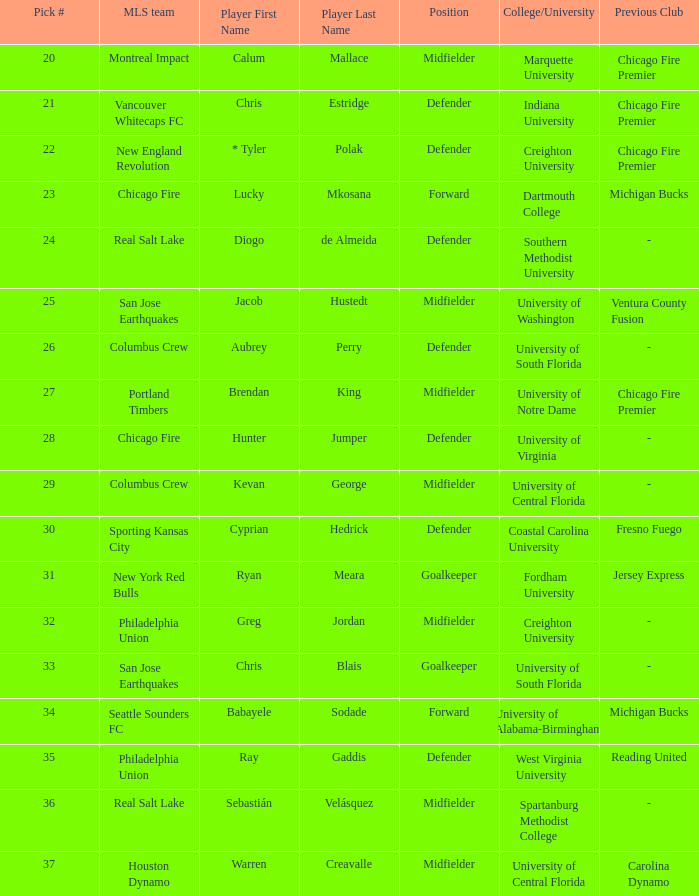I'm looking to parse the entire table for insights. Could you assist me with that? {'header': ['Pick #', 'MLS team', 'Player First Name', 'Player Last Name', 'Position', 'College/University', 'Previous Club'], 'rows': [['20', 'Montreal Impact', 'Calum', 'Mallace', 'Midfielder', 'Marquette University', 'Chicago Fire Premier'], ['21', 'Vancouver Whitecaps FC', 'Chris', 'Estridge', 'Defender', 'Indiana University', 'Chicago Fire Premier'], ['22', 'New England Revolution', '* Tyler', 'Polak', 'Defender', 'Creighton University', 'Chicago Fire Premier'], ['23', 'Chicago Fire', 'Lucky', 'Mkosana', 'Forward', 'Dartmouth College', 'Michigan Bucks'], ['24', 'Real Salt Lake', 'Diogo', 'de Almeida', 'Defender', 'Southern Methodist University', '-'], ['25', 'San Jose Earthquakes', 'Jacob', 'Hustedt', 'Midfielder', 'University of Washington', 'Ventura County Fusion'], ['26', 'Columbus Crew', 'Aubrey', 'Perry', 'Defender', 'University of South Florida', '-'], ['27', 'Portland Timbers', 'Brendan', 'King', 'Midfielder', 'University of Notre Dame', 'Chicago Fire Premier'], ['28', 'Chicago Fire', 'Hunter', 'Jumper', 'Defender', 'University of Virginia', '-'], ['29', 'Columbus Crew', 'Kevan', 'George', 'Midfielder', 'University of Central Florida', '-'], ['30', 'Sporting Kansas City', 'Cyprian', 'Hedrick', 'Defender', 'Coastal Carolina University', 'Fresno Fuego'], ['31', 'New York Red Bulls', 'Ryan', 'Meara', 'Goalkeeper', 'Fordham University', 'Jersey Express'], ['32', 'Philadelphia Union', 'Greg', 'Jordan', 'Midfielder', 'Creighton University', '-'], ['33', 'San Jose Earthquakes', 'Chris', 'Blais', 'Goalkeeper', 'University of South Florida', '-'], ['34', 'Seattle Sounders FC', 'Babayele', 'Sodade', 'Forward', 'University of Alabama-Birmingham', 'Michigan Bucks'], ['35', 'Philadelphia Union', 'Ray', 'Gaddis', 'Defender', 'West Virginia University', 'Reading United'], ['36', 'Real Salt Lake', 'Sebastián', 'Velásquez', 'Midfielder', 'Spartanburg Methodist College', '-'], ['37', 'Houston Dynamo', 'Warren', 'Creavalle', 'Midfielder', 'University of Central Florida', 'Carolina Dynamo']]} What MLS team picked Babayele Sodade? Seattle Sounders FC. 